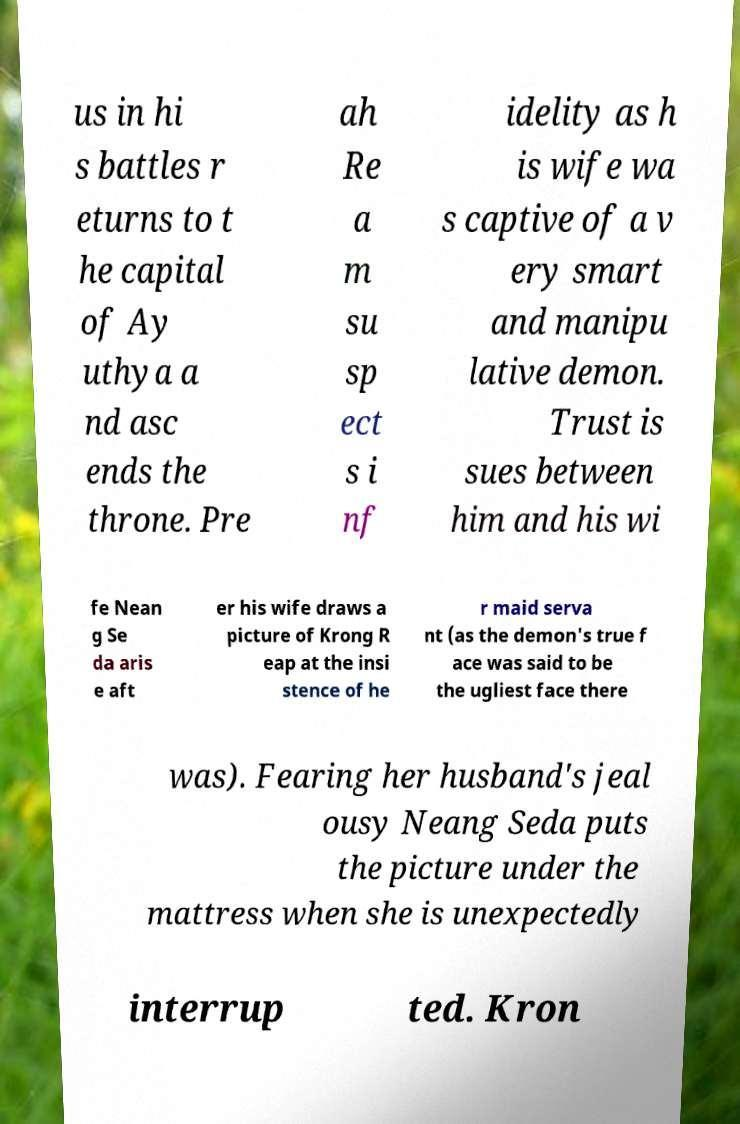Can you accurately transcribe the text from the provided image for me? us in hi s battles r eturns to t he capital of Ay uthya a nd asc ends the throne. Pre ah Re a m su sp ect s i nf idelity as h is wife wa s captive of a v ery smart and manipu lative demon. Trust is sues between him and his wi fe Nean g Se da aris e aft er his wife draws a picture of Krong R eap at the insi stence of he r maid serva nt (as the demon's true f ace was said to be the ugliest face there was). Fearing her husband's jeal ousy Neang Seda puts the picture under the mattress when she is unexpectedly interrup ted. Kron 